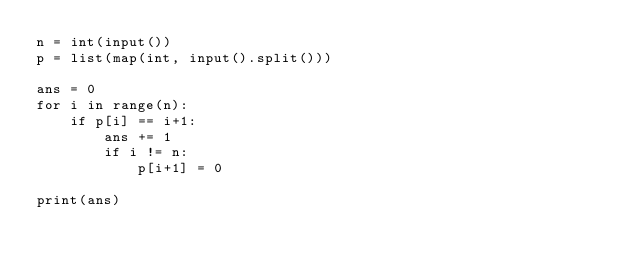Convert code to text. <code><loc_0><loc_0><loc_500><loc_500><_Python_>n = int(input())
p = list(map(int, input().split()))  

ans = 0
for i in range(n):
    if p[i] == i+1:
        ans += 1
        if i != n:
            p[i+1] = 0

print(ans)</code> 